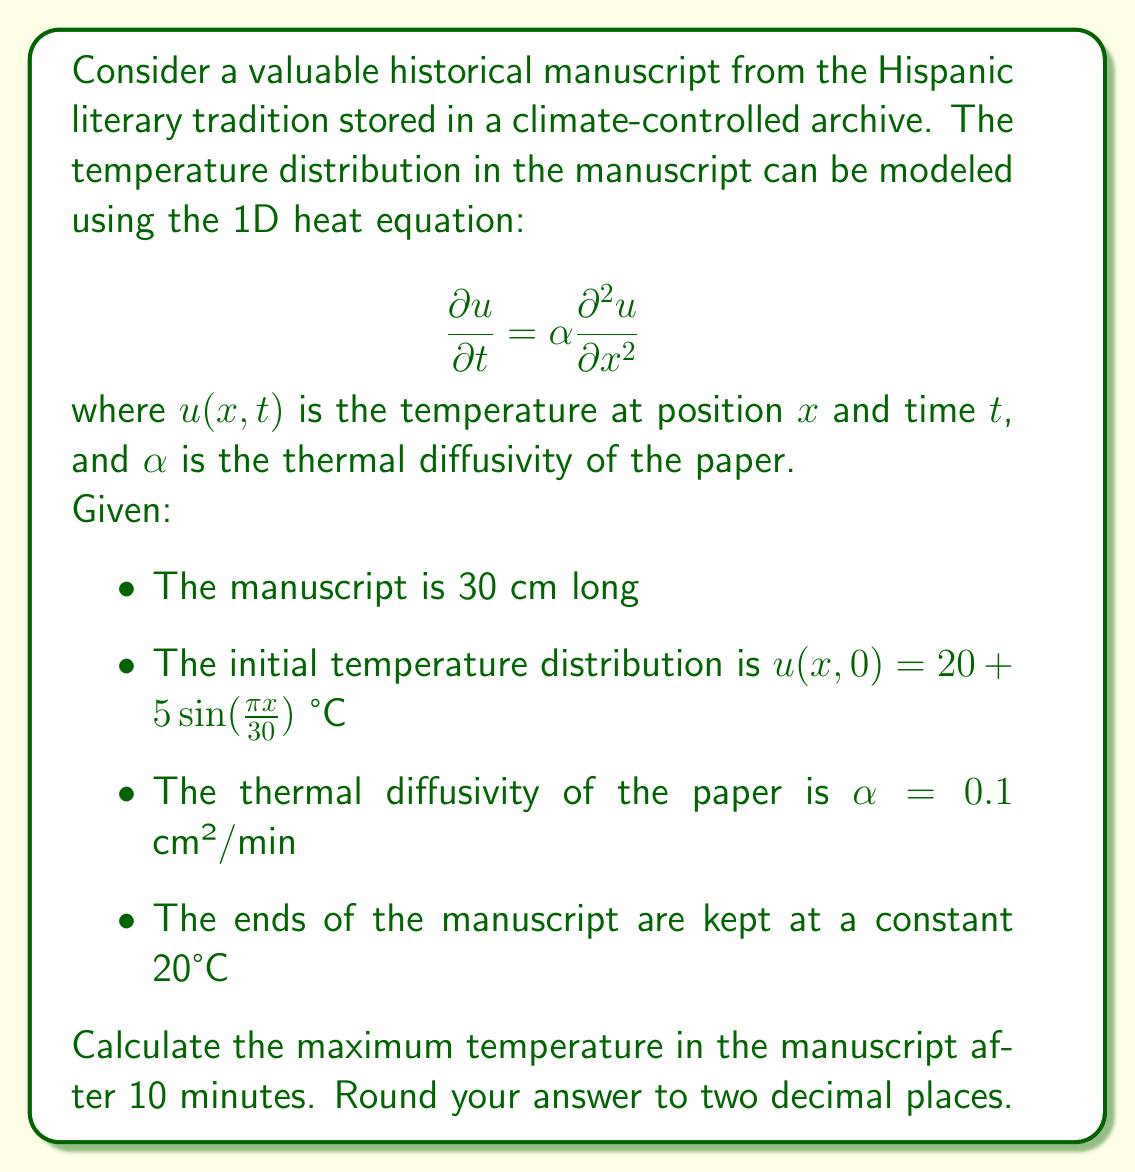Can you solve this math problem? To solve this problem, we need to use the method of separation of variables for the heat equation.

1) First, we express the solution as a product of two functions:
   $u(x,t) = X(x)T(t)$

2) Substituting this into the heat equation and separating variables:
   $$\frac{T'(t)}{T(t)} = \alpha \frac{X''(x)}{X(x)} = -\lambda$$
   where $\lambda$ is a constant.

3) This gives us two ODEs:
   $T'(t) + \alpha\lambda T(t) = 0$
   $X''(x) + \lambda X(x) = 0$

4) Given the boundary conditions (u = 20°C at x = 0 and x = 30), we can determine that:
   $\lambda_n = (\frac{n\pi}{30})^2$, where n = 1, 2, 3, ...

5) The general solution is:
   $$u(x,t) = 20 + \sum_{n=1}^{\infty} B_n \sin(\frac{n\pi x}{30}) e^{-\alpha (\frac{n\pi}{30})^2 t}$$

6) To match the initial condition, we need:
   $$20 + 5\sin(\frac{\pi x}{30}) = 20 + \sum_{n=1}^{\infty} B_n \sin(\frac{n\pi x}{30})$$

7) This implies $B_1 = 5$ and $B_n = 0$ for $n > 1$

8) Therefore, our solution is:
   $$u(x,t) = 20 + 5\sin(\frac{\pi x}{30}) e^{-\alpha (\frac{\pi}{30})^2 t}$$

9) After 10 minutes, the temperature distribution is:
   $$u(x,10) = 20 + 5\sin(\frac{\pi x}{30}) e^{-0.1 (\frac{\pi}{30})^2 10}$$

10) The maximum temperature will occur at x = 15 cm (the midpoint). Calculating:
    $$u(15,10) = 20 + 5 \cdot 1 \cdot e^{-0.1 (\frac{\pi}{30})^2 10} = 20 + 5e^{-0.034556} = 24.83°C$$
Answer: 24.83°C 